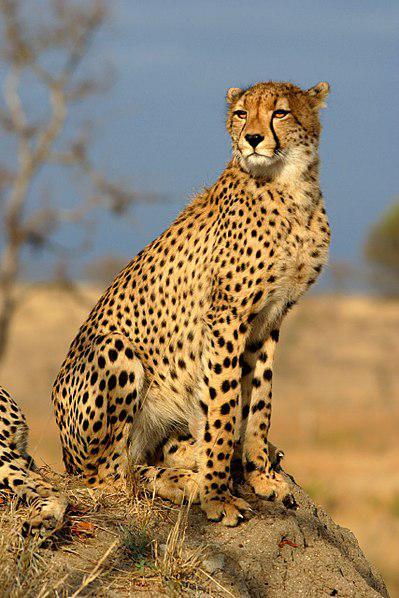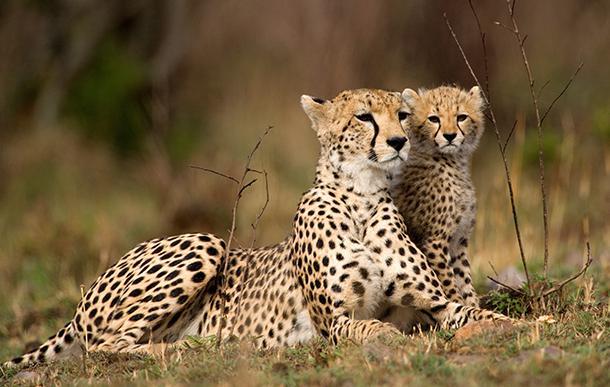The first image is the image on the left, the second image is the image on the right. For the images displayed, is the sentence "One image shows a reclining adult spotted wild cat posed with a cub." factually correct? Answer yes or no. Yes. The first image is the image on the left, the second image is the image on the right. Evaluate the accuracy of this statement regarding the images: "In one of the images there are two cheetahs laying next to each other.". Is it true? Answer yes or no. Yes. 